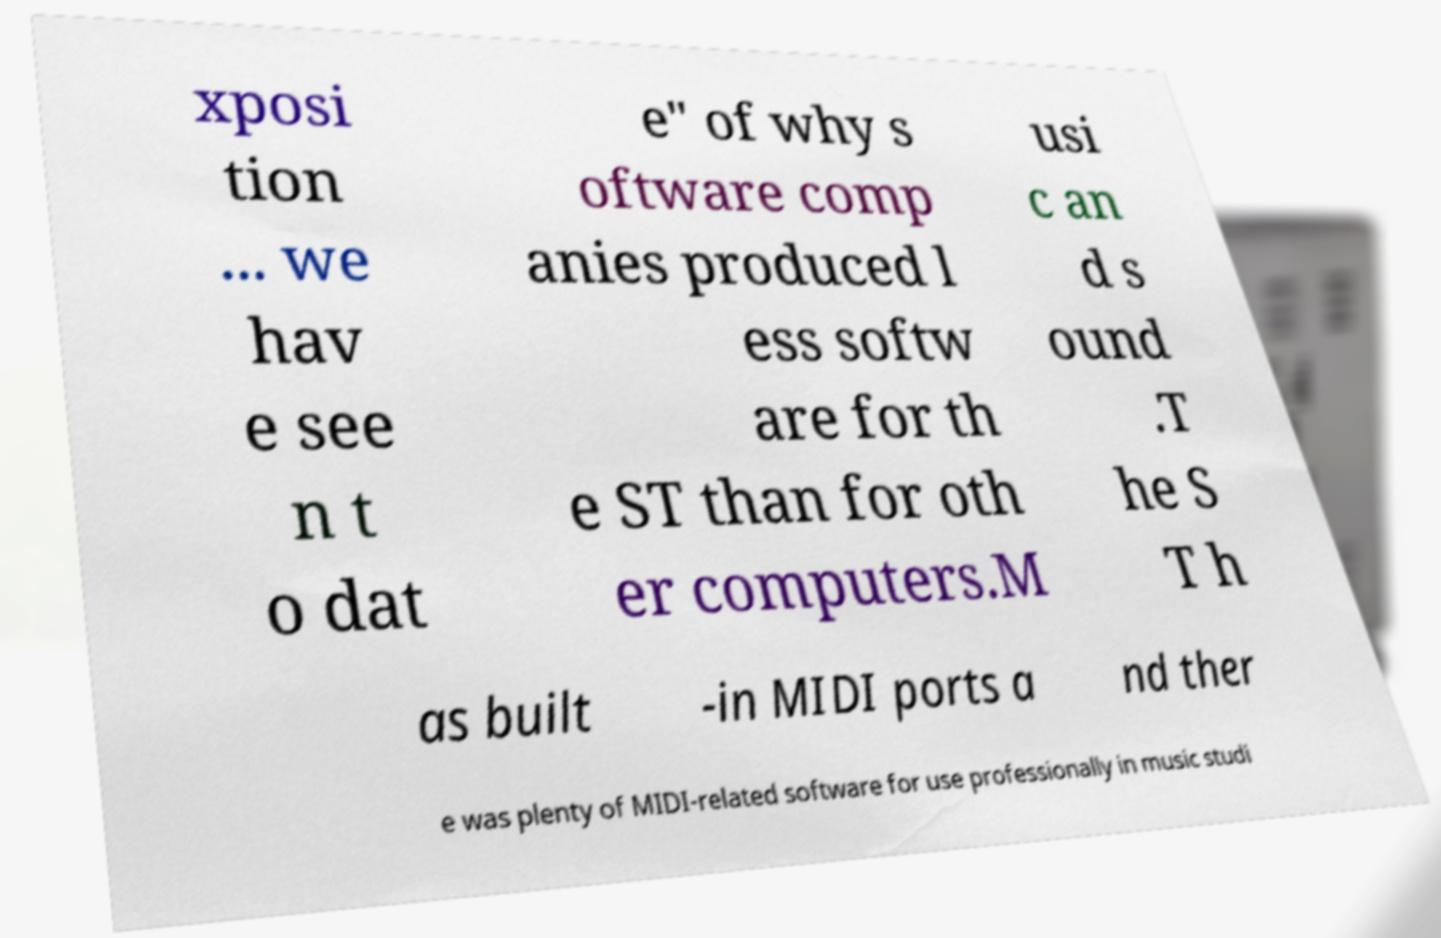Can you accurately transcribe the text from the provided image for me? xposi tion ... we hav e see n t o dat e" of why s oftware comp anies produced l ess softw are for th e ST than for oth er computers.M usi c an d s ound .T he S T h as built -in MIDI ports a nd ther e was plenty of MIDI-related software for use professionally in music studi 